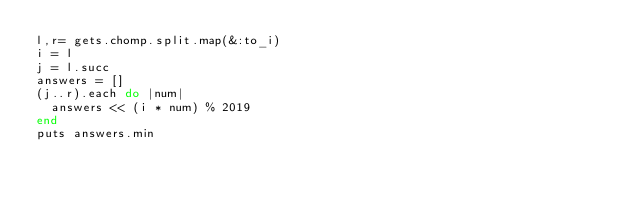Convert code to text. <code><loc_0><loc_0><loc_500><loc_500><_Ruby_>l,r= gets.chomp.split.map(&:to_i)
i = l
j = l.succ
answers = []
(j..r).each do |num|
  answers << (i * num) % 2019
end
puts answers.min</code> 